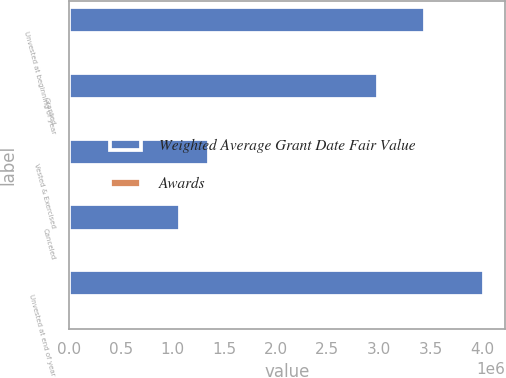<chart> <loc_0><loc_0><loc_500><loc_500><stacked_bar_chart><ecel><fcel>Unvested at beginning of year<fcel>Granted<fcel>Vested & Exercised<fcel>Canceled<fcel>Unvested at end of year<nl><fcel>Weighted Average Grant Date Fair Value<fcel>3.44835e+06<fcel>2.99456e+06<fcel>1.35034e+06<fcel>1.07522e+06<fcel>4.01734e+06<nl><fcel>Awards<fcel>34.04<fcel>28.9<fcel>33.4<fcel>32.7<fcel>30.76<nl></chart> 